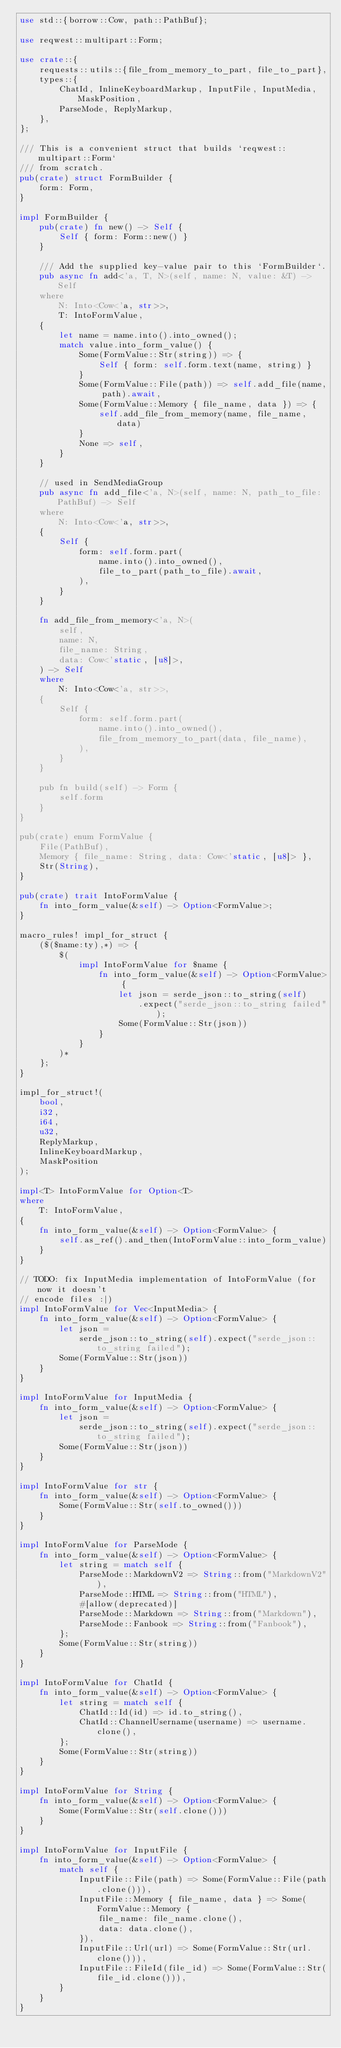Convert code to text. <code><loc_0><loc_0><loc_500><loc_500><_Rust_>use std::{borrow::Cow, path::PathBuf};

use reqwest::multipart::Form;

use crate::{
    requests::utils::{file_from_memory_to_part, file_to_part},
    types::{
        ChatId, InlineKeyboardMarkup, InputFile, InputMedia, MaskPosition,
        ParseMode, ReplyMarkup,
    },
};

/// This is a convenient struct that builds `reqwest::multipart::Form`
/// from scratch.
pub(crate) struct FormBuilder {
    form: Form,
}

impl FormBuilder {
    pub(crate) fn new() -> Self {
        Self { form: Form::new() }
    }

    /// Add the supplied key-value pair to this `FormBuilder`.
    pub async fn add<'a, T, N>(self, name: N, value: &T) -> Self
    where
        N: Into<Cow<'a, str>>,
        T: IntoFormValue,
    {
        let name = name.into().into_owned();
        match value.into_form_value() {
            Some(FormValue::Str(string)) => {
                Self { form: self.form.text(name, string) }
            }
            Some(FormValue::File(path)) => self.add_file(name, path).await,
            Some(FormValue::Memory { file_name, data }) => {
                self.add_file_from_memory(name, file_name, data)
            }
            None => self,
        }
    }

    // used in SendMediaGroup
    pub async fn add_file<'a, N>(self, name: N, path_to_file: PathBuf) -> Self
    where
        N: Into<Cow<'a, str>>,
    {
        Self {
            form: self.form.part(
                name.into().into_owned(),
                file_to_part(path_to_file).await,
            ),
        }
    }

    fn add_file_from_memory<'a, N>(
        self,
        name: N,
        file_name: String,
        data: Cow<'static, [u8]>,
    ) -> Self
    where
        N: Into<Cow<'a, str>>,
    {
        Self {
            form: self.form.part(
                name.into().into_owned(),
                file_from_memory_to_part(data, file_name),
            ),
        }
    }

    pub fn build(self) -> Form {
        self.form
    }
}

pub(crate) enum FormValue {
    File(PathBuf),
    Memory { file_name: String, data: Cow<'static, [u8]> },
    Str(String),
}

pub(crate) trait IntoFormValue {
    fn into_form_value(&self) -> Option<FormValue>;
}

macro_rules! impl_for_struct {
    ($($name:ty),*) => {
        $(
            impl IntoFormValue for $name {
                fn into_form_value(&self) -> Option<FormValue> {
                    let json = serde_json::to_string(self)
                        .expect("serde_json::to_string failed");
                    Some(FormValue::Str(json))
                }
            }
        )*
    };
}

impl_for_struct!(
    bool,
    i32,
    i64,
    u32,
    ReplyMarkup,
    InlineKeyboardMarkup,
    MaskPosition
);

impl<T> IntoFormValue for Option<T>
where
    T: IntoFormValue,
{
    fn into_form_value(&self) -> Option<FormValue> {
        self.as_ref().and_then(IntoFormValue::into_form_value)
    }
}

// TODO: fix InputMedia implementation of IntoFormValue (for now it doesn't
// encode files :|)
impl IntoFormValue for Vec<InputMedia> {
    fn into_form_value(&self) -> Option<FormValue> {
        let json =
            serde_json::to_string(self).expect("serde_json::to_string failed");
        Some(FormValue::Str(json))
    }
}

impl IntoFormValue for InputMedia {
    fn into_form_value(&self) -> Option<FormValue> {
        let json =
            serde_json::to_string(self).expect("serde_json::to_string failed");
        Some(FormValue::Str(json))
    }
}

impl IntoFormValue for str {
    fn into_form_value(&self) -> Option<FormValue> {
        Some(FormValue::Str(self.to_owned()))
    }
}

impl IntoFormValue for ParseMode {
    fn into_form_value(&self) -> Option<FormValue> {
        let string = match self {
            ParseMode::MarkdownV2 => String::from("MarkdownV2"),
            ParseMode::HTML => String::from("HTML"),
            #[allow(deprecated)]
            ParseMode::Markdown => String::from("Markdown"),
            ParseMode::Fanbook => String::from("Fanbook"),
        };
        Some(FormValue::Str(string))
    }
}

impl IntoFormValue for ChatId {
    fn into_form_value(&self) -> Option<FormValue> {
        let string = match self {
            ChatId::Id(id) => id.to_string(),
            ChatId::ChannelUsername(username) => username.clone(),
        };
        Some(FormValue::Str(string))
    }
}

impl IntoFormValue for String {
    fn into_form_value(&self) -> Option<FormValue> {
        Some(FormValue::Str(self.clone()))
    }
}

impl IntoFormValue for InputFile {
    fn into_form_value(&self) -> Option<FormValue> {
        match self {
            InputFile::File(path) => Some(FormValue::File(path.clone())),
            InputFile::Memory { file_name, data } => Some(FormValue::Memory {
                file_name: file_name.clone(),
                data: data.clone(),
            }),
            InputFile::Url(url) => Some(FormValue::Str(url.clone())),
            InputFile::FileId(file_id) => Some(FormValue::Str(file_id.clone())),
        }
    }
}
</code> 